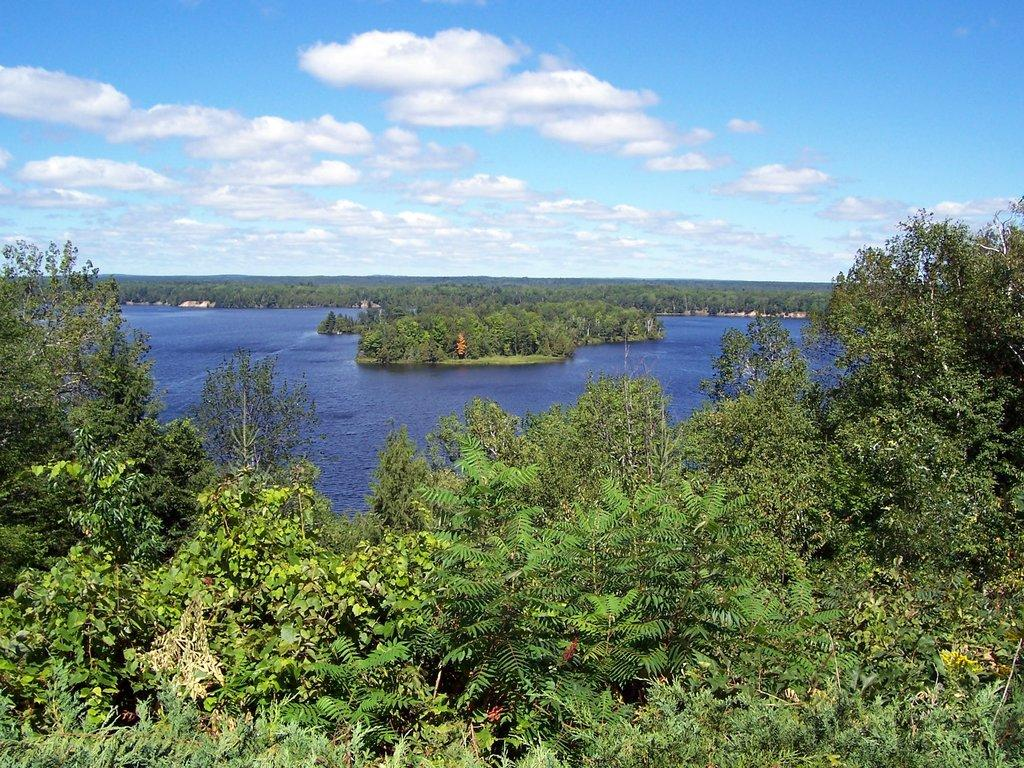What type of vegetation can be seen in the image? There is a group of trees in the image. What natural element is visible besides the trees? There is water visible in the image. What is the condition of the sky in the background of the image? The sky is cloudy in the background of the image. What word is being compared to the trees in the image? There is no word being compared to the trees in the image. How does the knee relate to the image? There is no mention of a knee or any body part in the image. 